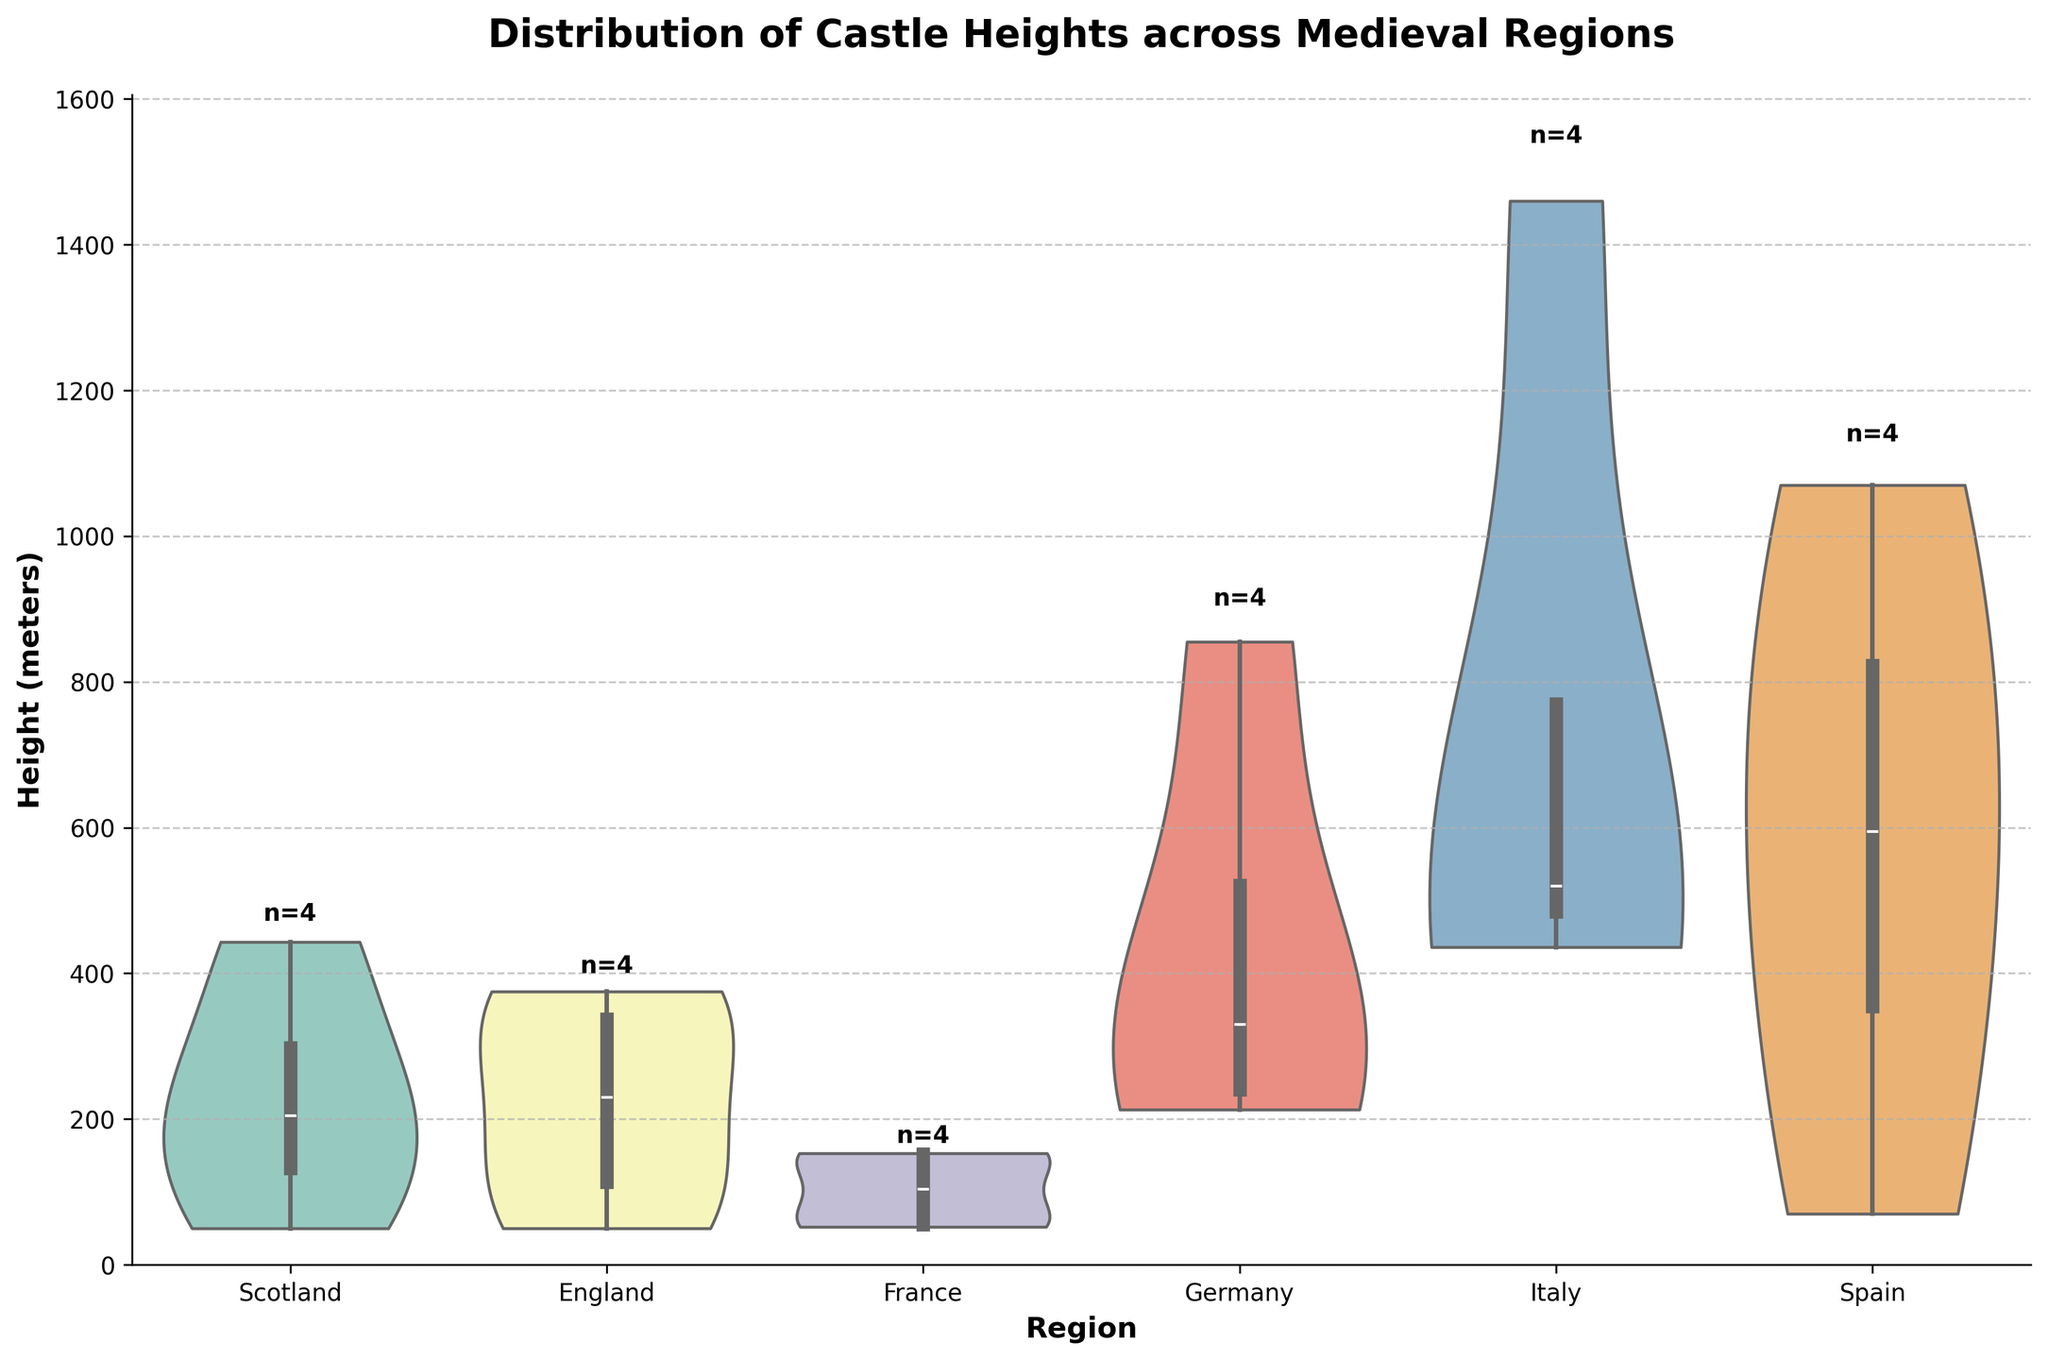what is the title of the figure? The title of the chart is shown at the top center of the figure. Reading the text there gives us, "Distribution of Castle Heights across Medieval Regions."
Answer: Distribution of Castle Heights across Medieval Regions what is the range of castle heights in Scotland? From the violin plot for Scotland, the highest point reaches around 443 meters, and the lowest touches approximately 50 meters.
Answer: 50-443 meters which region has the highest castle height? By observing the peaks of the violin plots, the tallest peak corresponds to Spain, with the highest measurement reaching about 1070 meters.
Answer: Spain how many castles are represented in the region of France? Each region has an annotation showing the number of castles. Reading the text for France indicates four castles (n=4).
Answer: 4 which region shows the most variability in castle heights? The width and spread of the violin plots indicate variability. Germany shows a wide and diverse spread, indicating high variability in the castle heights.
Answer: Germany what is the average height of castles in Italy if you exclude the highest castle? Italy's heights are 436, 1460, 540, and 501 meters. Excluding 1460, the remaining heights are 436, 540, and 501. Average = (436 + 540 + 501) / 3 = 492
Answer: 492 meters between England and Scotland, which region has taller castles on average? Comparing the central tendency or median line within each region's violin plot, Scotland's tends to lean higher.
Answer: Scotland does the distribution of heights in Spain have outliers, and if so, what are they? Spain’s violin plot has a wider spread and isolated points (e.g., Castillo de Loarre at 1070 meters and Alhambra at 740 meters). These beyond the interquartile range represent outliers.
Answer: Yes, 1070 and 740 meters what is the interquartile range (IQR) for castle heights in Germany? Visually, the IQR is the width of the main "violin" body. The quartiles appear around 210 and 450 meters. So, IQR roughly = 450 - 210 = 240 meters.
Answer: 240 meters how many castles are taller than 500 meters across all regions? Noting regions, individual heights above 500: Hohenzollern Castle (855m), Rocca Calascio (1460m), Castel del Monte (540m), Castello di Brolio (501m), Alhambra (740m), Castillo de Loarre (1070m). This totals six castles.
Answer: 6 